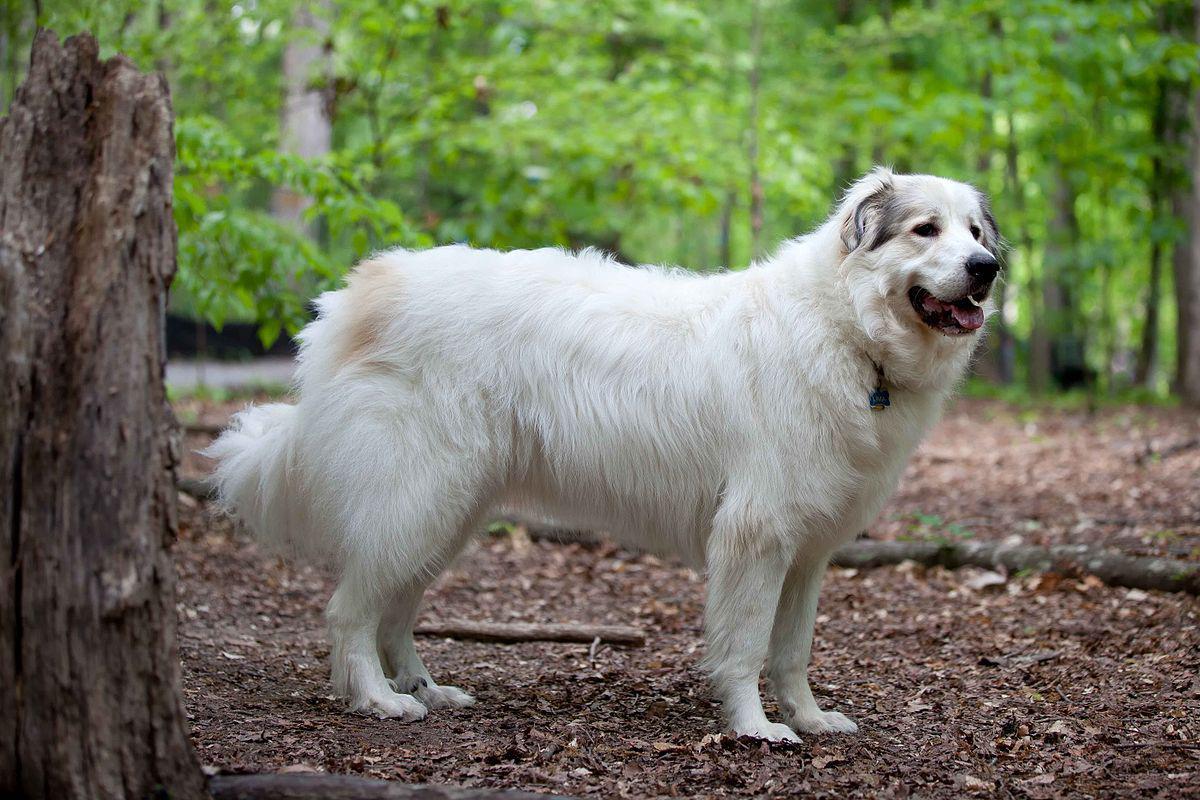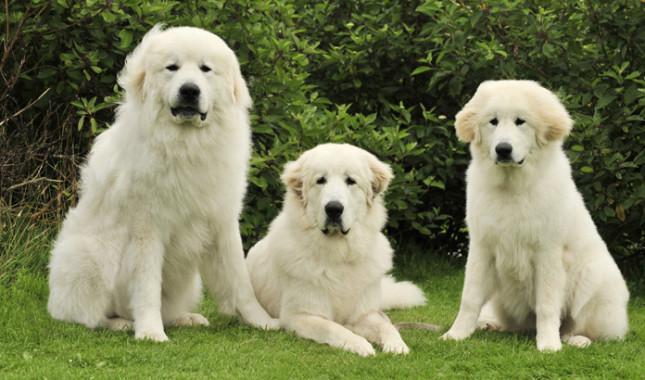The first image is the image on the left, the second image is the image on the right. Considering the images on both sides, is "An image contains one white dog standing in profile and turned leftward." valid? Answer yes or no. No. The first image is the image on the left, the second image is the image on the right. Evaluate the accuracy of this statement regarding the images: "There are two dogs in the image pair, both facing the same direction as the other.". Is it true? Answer yes or no. No. 